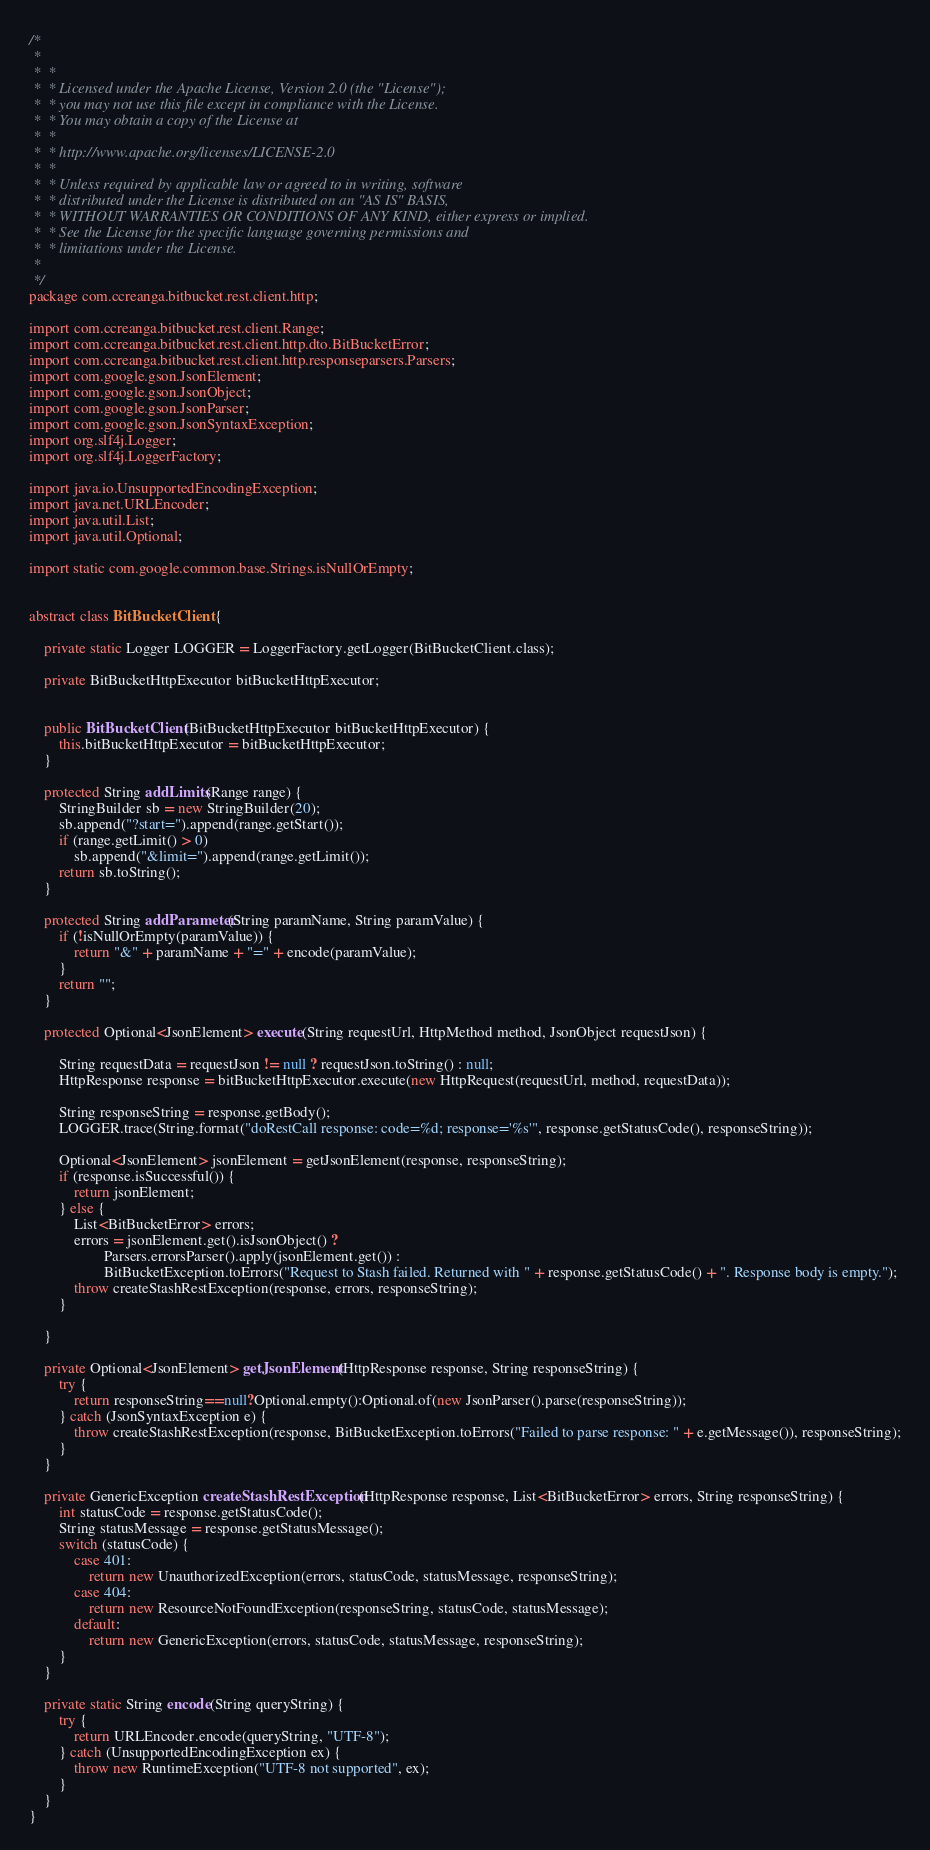Convert code to text. <code><loc_0><loc_0><loc_500><loc_500><_Java_>/*
 *
 *  *
 *  * Licensed under the Apache License, Version 2.0 (the "License");
 *  * you may not use this file except in compliance with the License.
 *  * You may obtain a copy of the License at
 *  *
 *  * http://www.apache.org/licenses/LICENSE-2.0
 *  *
 *  * Unless required by applicable law or agreed to in writing, software
 *  * distributed under the License is distributed on an "AS IS" BASIS,
 *  * WITHOUT WARRANTIES OR CONDITIONS OF ANY KIND, either express or implied.
 *  * See the License for the specific language governing permissions and
 *  * limitations under the License.
 *
 */
package com.ccreanga.bitbucket.rest.client.http;

import com.ccreanga.bitbucket.rest.client.Range;
import com.ccreanga.bitbucket.rest.client.http.dto.BitBucketError;
import com.ccreanga.bitbucket.rest.client.http.responseparsers.Parsers;
import com.google.gson.JsonElement;
import com.google.gson.JsonObject;
import com.google.gson.JsonParser;
import com.google.gson.JsonSyntaxException;
import org.slf4j.Logger;
import org.slf4j.LoggerFactory;

import java.io.UnsupportedEncodingException;
import java.net.URLEncoder;
import java.util.List;
import java.util.Optional;

import static com.google.common.base.Strings.isNullOrEmpty;


abstract class BitBucketClient {

    private static Logger LOGGER = LoggerFactory.getLogger(BitBucketClient.class);

    private BitBucketHttpExecutor bitBucketHttpExecutor;


    public BitBucketClient(BitBucketHttpExecutor bitBucketHttpExecutor) {
        this.bitBucketHttpExecutor = bitBucketHttpExecutor;
    }

    protected String addLimits(Range range) {
        StringBuilder sb = new StringBuilder(20);
        sb.append("?start=").append(range.getStart());
        if (range.getLimit() > 0)
            sb.append("&limit=").append(range.getLimit());
        return sb.toString();
    }

    protected String addParameter(String paramName, String paramValue) {
        if (!isNullOrEmpty(paramValue)) {
            return "&" + paramName + "=" + encode(paramValue);
        }
        return "";
    }

    protected Optional<JsonElement> execute(String requestUrl, HttpMethod method, JsonObject requestJson) {

        String requestData = requestJson != null ? requestJson.toString() : null;
        HttpResponse response = bitBucketHttpExecutor.execute(new HttpRequest(requestUrl, method, requestData));

        String responseString = response.getBody();
        LOGGER.trace(String.format("doRestCall response: code=%d; response='%s'", response.getStatusCode(), responseString));

        Optional<JsonElement> jsonElement = getJsonElement(response, responseString);
        if (response.isSuccessful()) {
            return jsonElement;
        } else {
            List<BitBucketError> errors;
            errors = jsonElement.get().isJsonObject() ?
                    Parsers.errorsParser().apply(jsonElement.get()) :
                    BitBucketException.toErrors("Request to Stash failed. Returned with " + response.getStatusCode() + ". Response body is empty.");
            throw createStashRestException(response, errors, responseString);
        }

    }

    private Optional<JsonElement> getJsonElement(HttpResponse response, String responseString) {
        try {
            return responseString==null?Optional.empty():Optional.of(new JsonParser().parse(responseString));
        } catch (JsonSyntaxException e) {
            throw createStashRestException(response, BitBucketException.toErrors("Failed to parse response: " + e.getMessage()), responseString);
        }
    }

    private GenericException createStashRestException(HttpResponse response, List<BitBucketError> errors, String responseString) {
        int statusCode = response.getStatusCode();
        String statusMessage = response.getStatusMessage();
        switch (statusCode) {
            case 401:
                return new UnauthorizedException(errors, statusCode, statusMessage, responseString);
            case 404:
                return new ResourceNotFoundException(responseString, statusCode, statusMessage);
            default:
                return new GenericException(errors, statusCode, statusMessage, responseString);
        }
    }

    private static String encode(String queryString) {
        try {
            return URLEncoder.encode(queryString, "UTF-8");
        } catch (UnsupportedEncodingException ex) {
            throw new RuntimeException("UTF-8 not supported", ex);
        }
    }
}
</code> 